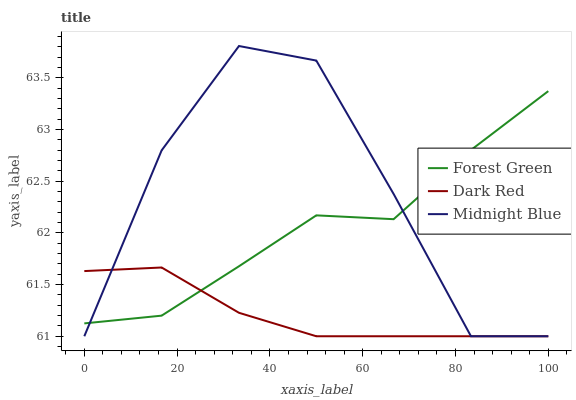Does Dark Red have the minimum area under the curve?
Answer yes or no. Yes. Does Midnight Blue have the maximum area under the curve?
Answer yes or no. Yes. Does Forest Green have the minimum area under the curve?
Answer yes or no. No. Does Forest Green have the maximum area under the curve?
Answer yes or no. No. Is Dark Red the smoothest?
Answer yes or no. Yes. Is Midnight Blue the roughest?
Answer yes or no. Yes. Is Forest Green the smoothest?
Answer yes or no. No. Is Forest Green the roughest?
Answer yes or no. No. Does Dark Red have the lowest value?
Answer yes or no. Yes. Does Forest Green have the lowest value?
Answer yes or no. No. Does Midnight Blue have the highest value?
Answer yes or no. Yes. Does Forest Green have the highest value?
Answer yes or no. No. Does Forest Green intersect Midnight Blue?
Answer yes or no. Yes. Is Forest Green less than Midnight Blue?
Answer yes or no. No. Is Forest Green greater than Midnight Blue?
Answer yes or no. No. 